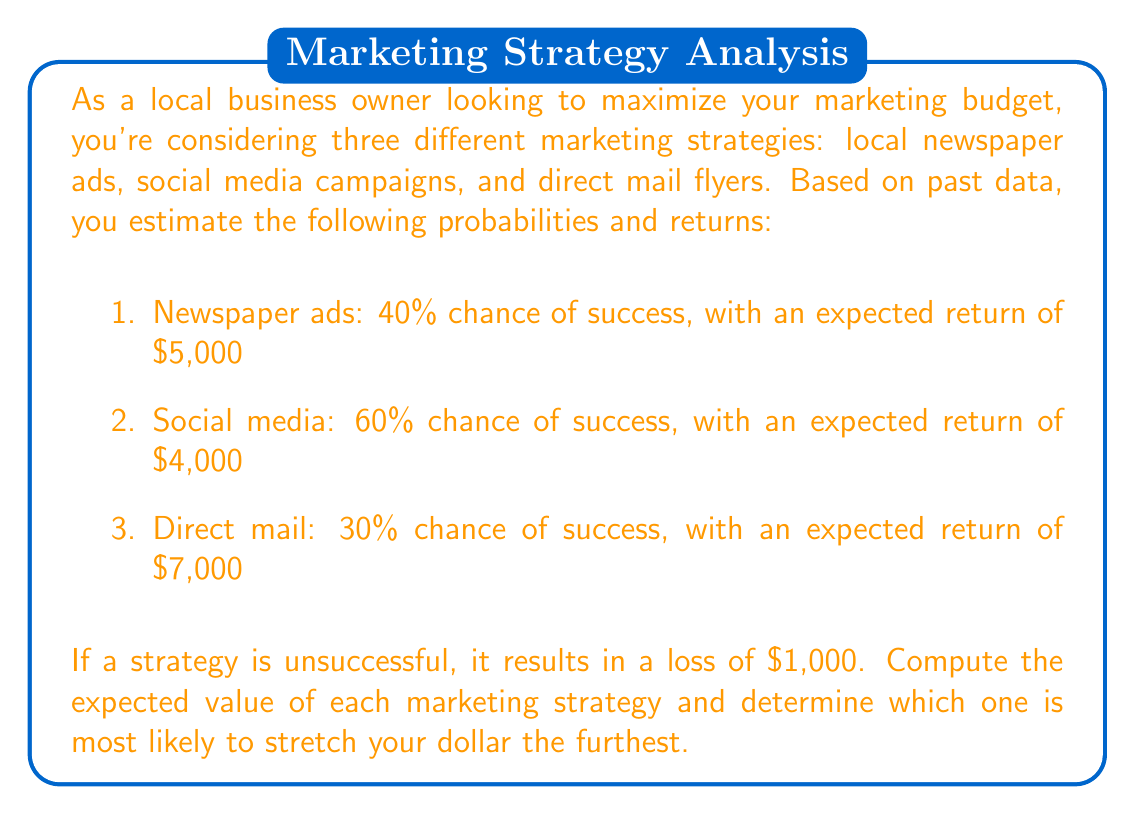What is the answer to this math problem? To solve this problem, we need to calculate the expected value for each marketing strategy. The expected value is the sum of each possible outcome multiplied by its probability.

Let's calculate the expected value for each strategy:

1. Newspaper ads:
   Success probability: 40% = 0.4
   Failure probability: 60% = 0.6
   
   Expected value = (Probability of success × Return on success) + (Probability of failure × Return on failure)
   $$E(\text{Newspaper}) = (0.4 \times \$5,000) + (0.6 \times (-\$1,000))$$
   $$E(\text{Newspaper}) = \$2,000 - \$600 = \$1,400$$

2. Social media:
   Success probability: 60% = 0.6
   Failure probability: 40% = 0.4
   
   $$E(\text{Social Media}) = (0.6 \times \$4,000) + (0.4 \times (-\$1,000))$$
   $$E(\text{Social Media}) = \$2,400 - \$400 = \$2,000$$

3. Direct mail:
   Success probability: 30% = 0.3
   Failure probability: 70% = 0.7
   
   $$E(\text{Direct Mail}) = (0.3 \times \$7,000) + (0.7 \times (-\$1,000))$$
   $$E(\text{Direct Mail}) = \$2,100 - \$700 = \$1,400$$

To determine which strategy stretches the dollar the furthest, we compare the expected values:

Social Media: $2,000
Newspaper ads: $1,400
Direct mail: $1,400

The social media campaign has the highest expected value, making it the strategy most likely to stretch your marketing dollar the furthest.
Answer: The expected values for each strategy are:
Newspaper ads: $1,400
Social media: $2,000
Direct mail: $1,400

The social media campaign has the highest expected value of $2,000, making it the most effective strategy for stretching your marketing dollar. 